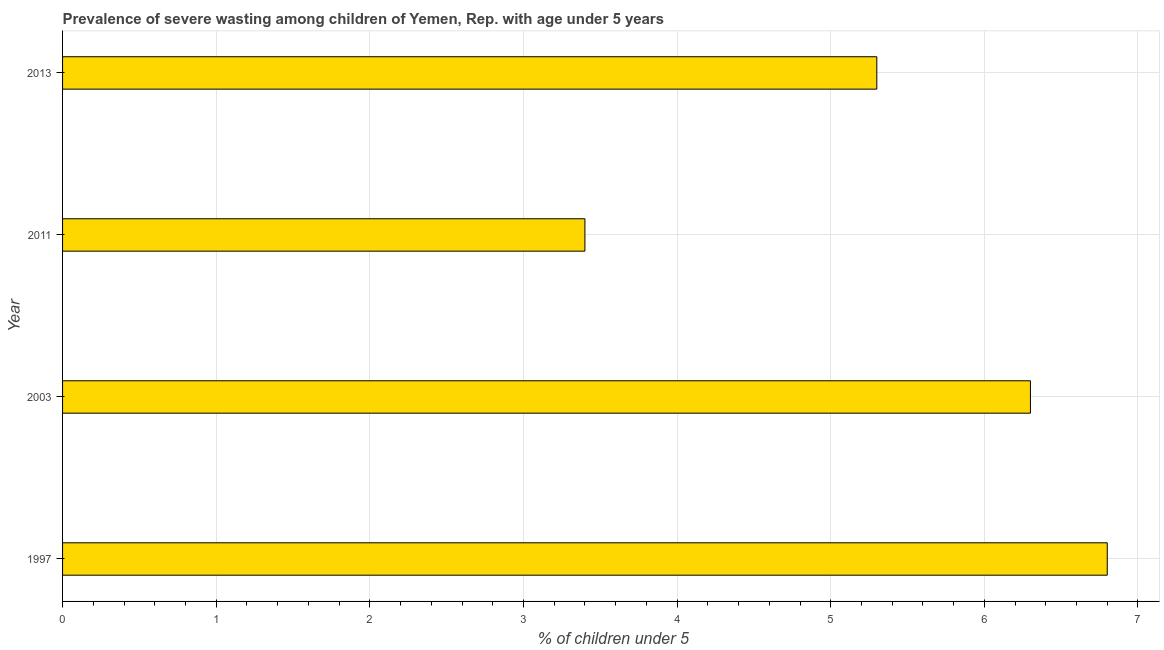Does the graph contain any zero values?
Make the answer very short. No. What is the title of the graph?
Provide a short and direct response. Prevalence of severe wasting among children of Yemen, Rep. with age under 5 years. What is the label or title of the X-axis?
Offer a terse response.  % of children under 5. What is the prevalence of severe wasting in 2003?
Offer a terse response. 6.3. Across all years, what is the maximum prevalence of severe wasting?
Your answer should be compact. 6.8. Across all years, what is the minimum prevalence of severe wasting?
Make the answer very short. 3.4. What is the sum of the prevalence of severe wasting?
Offer a very short reply. 21.8. What is the average prevalence of severe wasting per year?
Provide a short and direct response. 5.45. What is the median prevalence of severe wasting?
Make the answer very short. 5.8. What is the ratio of the prevalence of severe wasting in 1997 to that in 2011?
Provide a short and direct response. 2. Is the prevalence of severe wasting in 2003 less than that in 2013?
Your answer should be compact. No. Is the difference between the prevalence of severe wasting in 1997 and 2011 greater than the difference between any two years?
Keep it short and to the point. Yes. What is the difference between the highest and the lowest prevalence of severe wasting?
Offer a very short reply. 3.4. How many bars are there?
Offer a terse response. 4. Are all the bars in the graph horizontal?
Provide a short and direct response. Yes. What is the difference between two consecutive major ticks on the X-axis?
Your answer should be very brief. 1. What is the  % of children under 5 in 1997?
Your answer should be compact. 6.8. What is the  % of children under 5 of 2003?
Offer a terse response. 6.3. What is the  % of children under 5 of 2011?
Your answer should be very brief. 3.4. What is the  % of children under 5 in 2013?
Your answer should be compact. 5.3. What is the difference between the  % of children under 5 in 1997 and 2003?
Provide a succinct answer. 0.5. What is the difference between the  % of children under 5 in 1997 and 2011?
Offer a terse response. 3.4. What is the difference between the  % of children under 5 in 1997 and 2013?
Provide a short and direct response. 1.5. What is the difference between the  % of children under 5 in 2003 and 2013?
Ensure brevity in your answer.  1. What is the ratio of the  % of children under 5 in 1997 to that in 2003?
Your answer should be compact. 1.08. What is the ratio of the  % of children under 5 in 1997 to that in 2013?
Provide a short and direct response. 1.28. What is the ratio of the  % of children under 5 in 2003 to that in 2011?
Ensure brevity in your answer.  1.85. What is the ratio of the  % of children under 5 in 2003 to that in 2013?
Make the answer very short. 1.19. What is the ratio of the  % of children under 5 in 2011 to that in 2013?
Your answer should be compact. 0.64. 